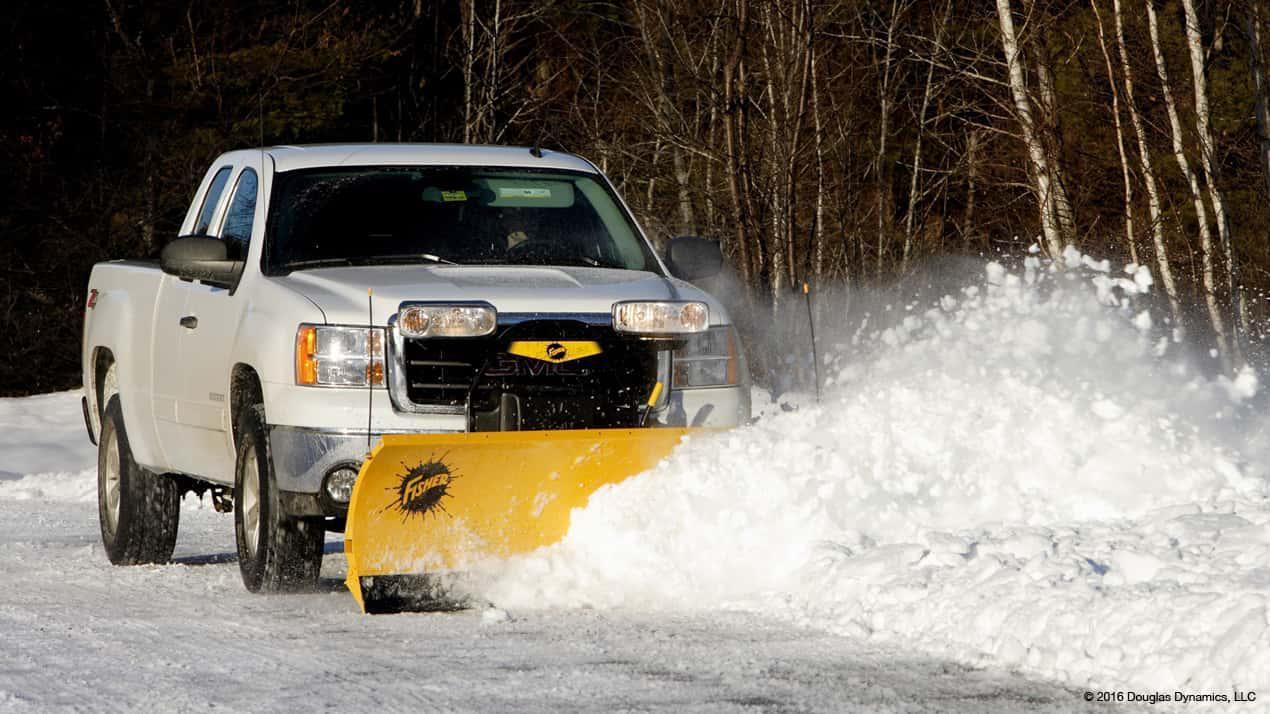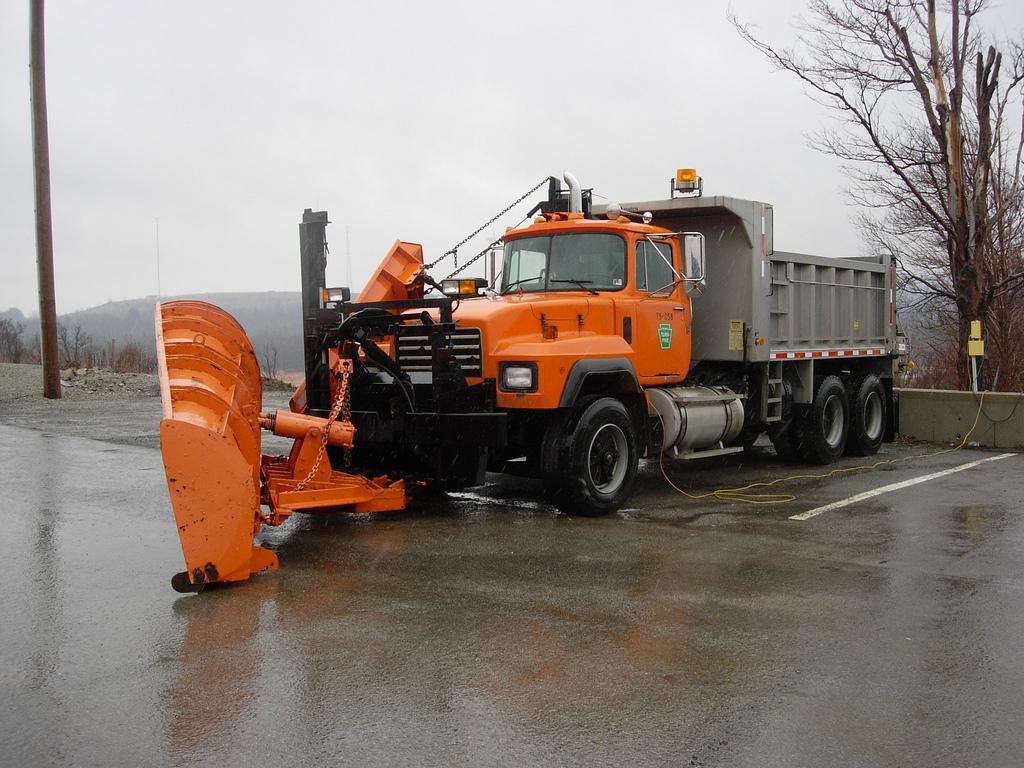The first image is the image on the left, the second image is the image on the right. For the images displayed, is the sentence "An orange truck has a plow on the front of it." factually correct? Answer yes or no. Yes. The first image is the image on the left, the second image is the image on the right. Considering the images on both sides, is "An image features a truck with an orange plow and orange cab." valid? Answer yes or no. Yes. The first image is the image on the left, the second image is the image on the right. Considering the images on both sides, is "Snow cascades off of the plow in the image on the left." valid? Answer yes or no. Yes. 